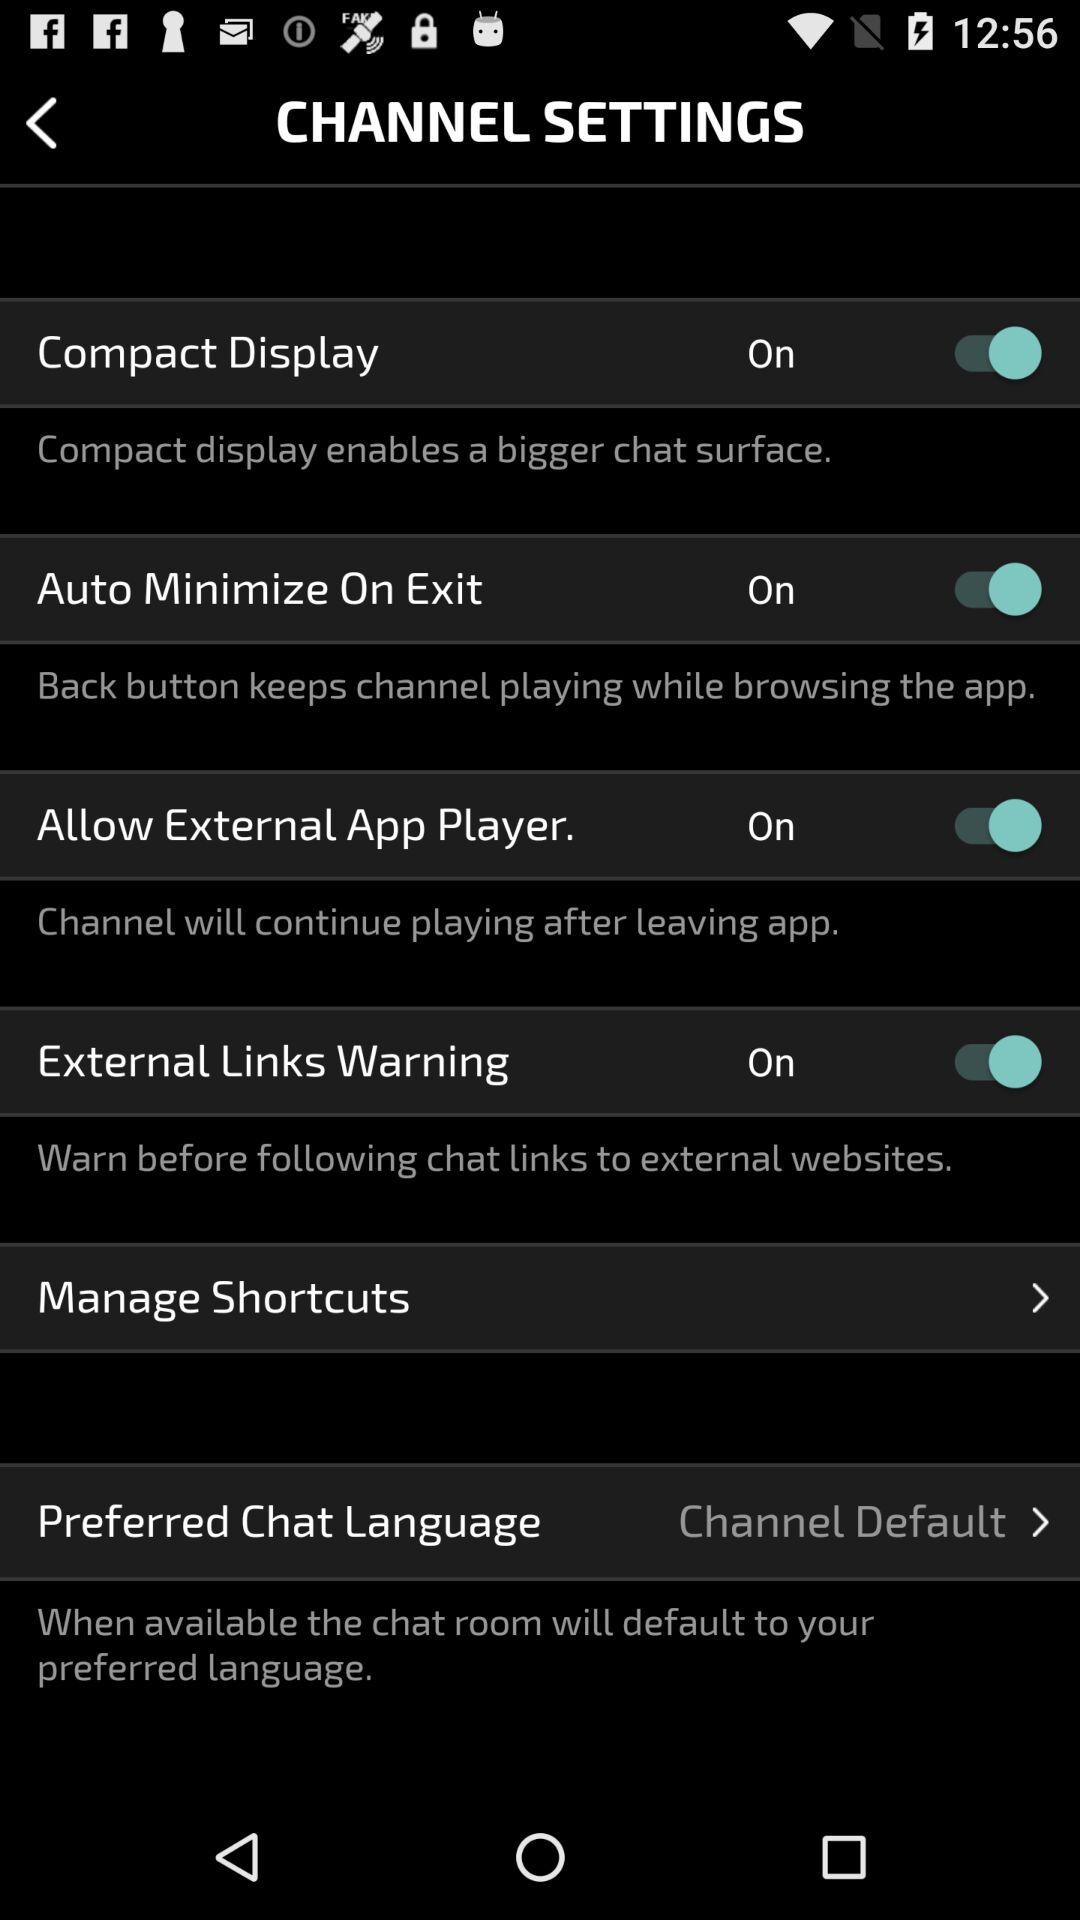What is the status of "Compact Display"? The status of "Compact Display" is "on". 